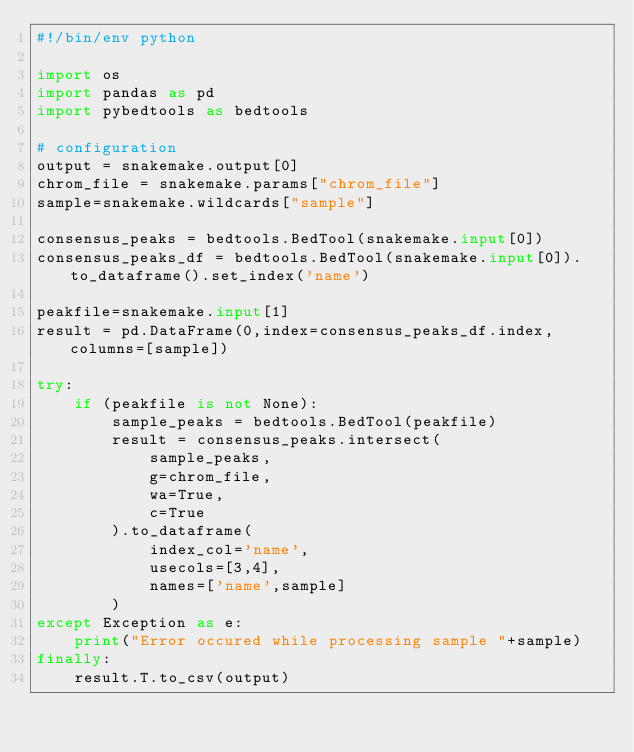Convert code to text. <code><loc_0><loc_0><loc_500><loc_500><_Python_>#!/bin/env python

import os
import pandas as pd
import pybedtools as bedtools

# configuration
output = snakemake.output[0]
chrom_file = snakemake.params["chrom_file"]
sample=snakemake.wildcards["sample"]

consensus_peaks = bedtools.BedTool(snakemake.input[0])
consensus_peaks_df = bedtools.BedTool(snakemake.input[0]).to_dataframe().set_index('name')

peakfile=snakemake.input[1]
result = pd.DataFrame(0,index=consensus_peaks_df.index,columns=[sample])
    
try:
    if (peakfile is not None):
        sample_peaks = bedtools.BedTool(peakfile)
        result = consensus_peaks.intersect(
            sample_peaks,
            g=chrom_file, 
            wa=True,
            c=True
        ).to_dataframe(
            index_col='name',
            usecols=[3,4],
            names=['name',sample]
        )
except Exception as e:
    print("Error occured while processing sample "+sample)
finally:
    result.T.to_csv(output)</code> 